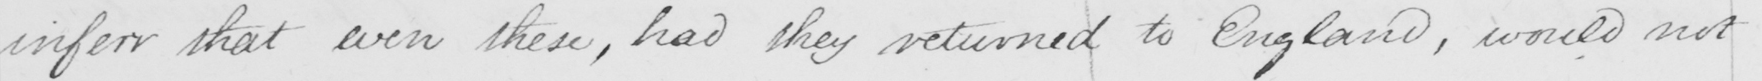Transcribe the text shown in this historical manuscript line. inferr that even these , had they returned to England , would not 